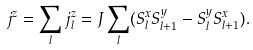<formula> <loc_0><loc_0><loc_500><loc_500>j ^ { z } = \sum _ { l } j ^ { z } _ { l } = J \sum _ { l } ( S _ { l } ^ { x } S _ { l + 1 } ^ { y } - S _ { l } ^ { y } S _ { l + 1 } ^ { x } ) .</formula> 